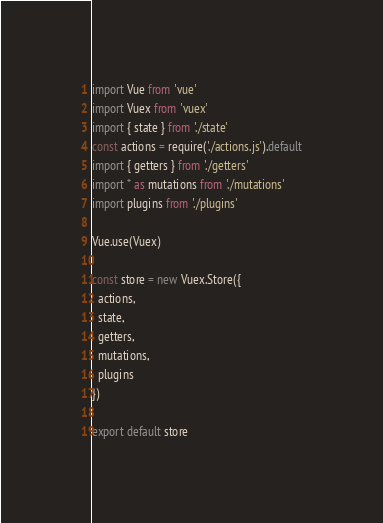<code> <loc_0><loc_0><loc_500><loc_500><_JavaScript_>import Vue from 'vue'
import Vuex from 'vuex'
import { state } from './state'
const actions = require('./actions.js').default
import { getters } from './getters'
import * as mutations from './mutations'
import plugins from './plugins'

Vue.use(Vuex)

const store = new Vuex.Store({
  actions,
  state,
  getters,
  mutations,
  plugins
})

export default store
</code> 